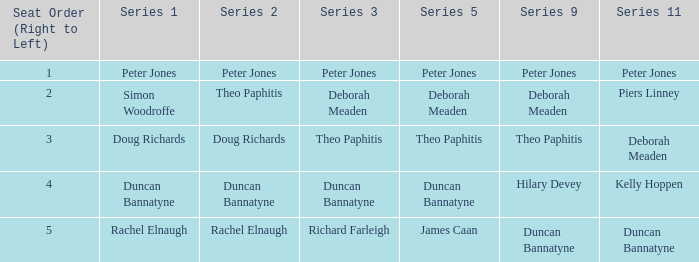Which series 2 includes a series 3 with deborah meaden? Theo Paphitis. 